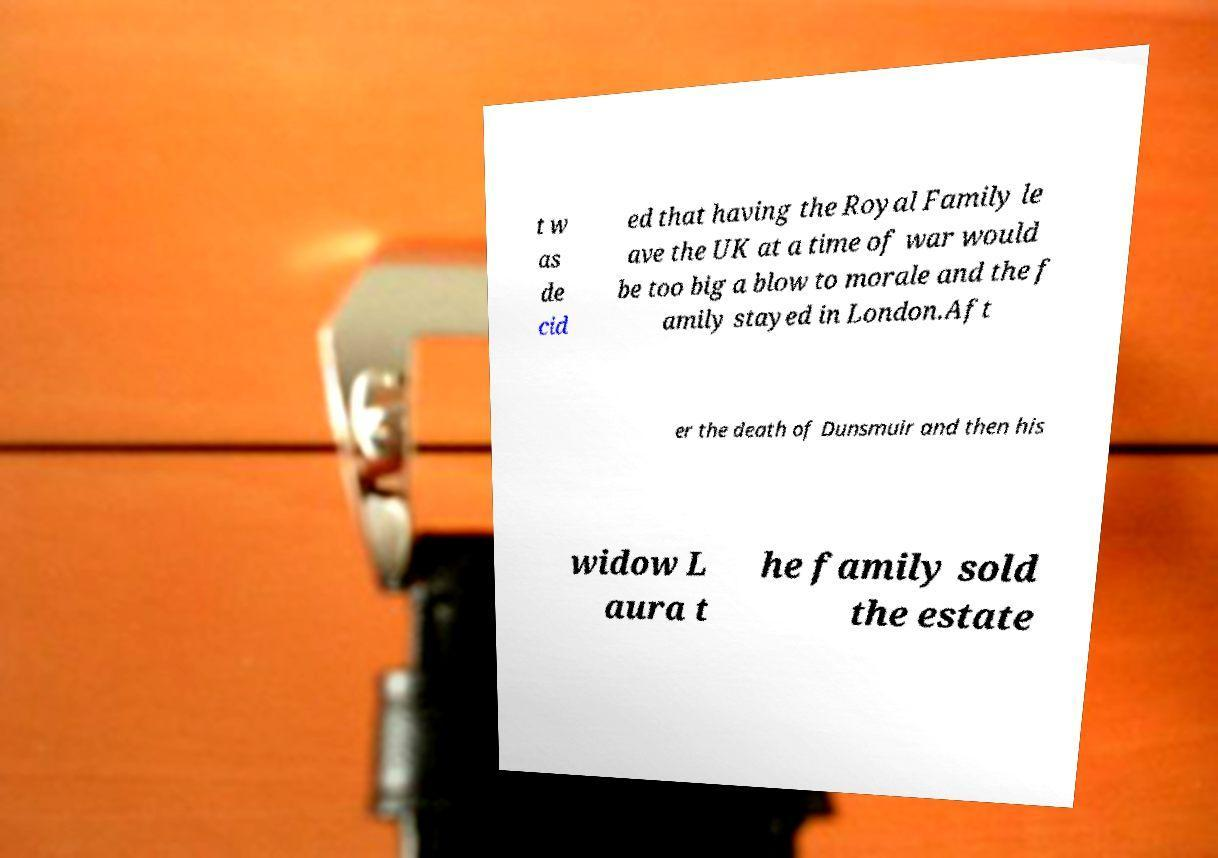There's text embedded in this image that I need extracted. Can you transcribe it verbatim? t w as de cid ed that having the Royal Family le ave the UK at a time of war would be too big a blow to morale and the f amily stayed in London.Aft er the death of Dunsmuir and then his widow L aura t he family sold the estate 